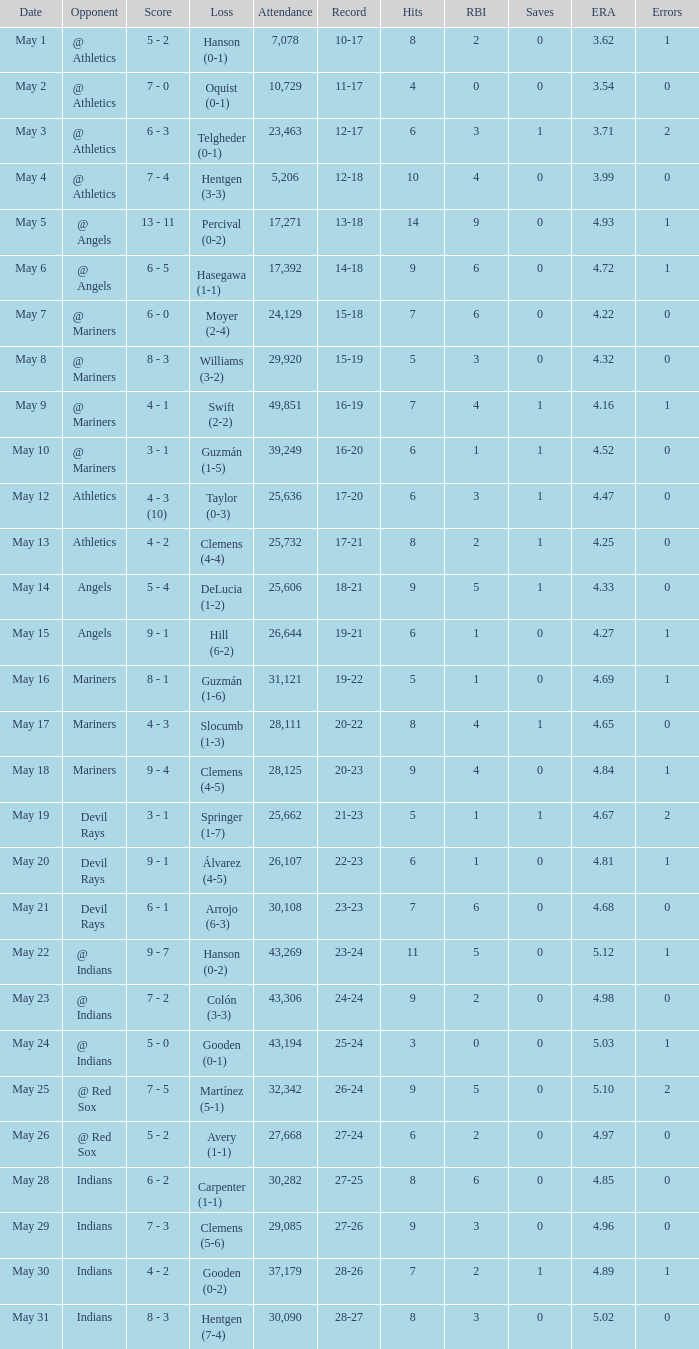When the record shows 16-20 and the crowd exceeds 32,342, can you determine the score? 3 - 1. 